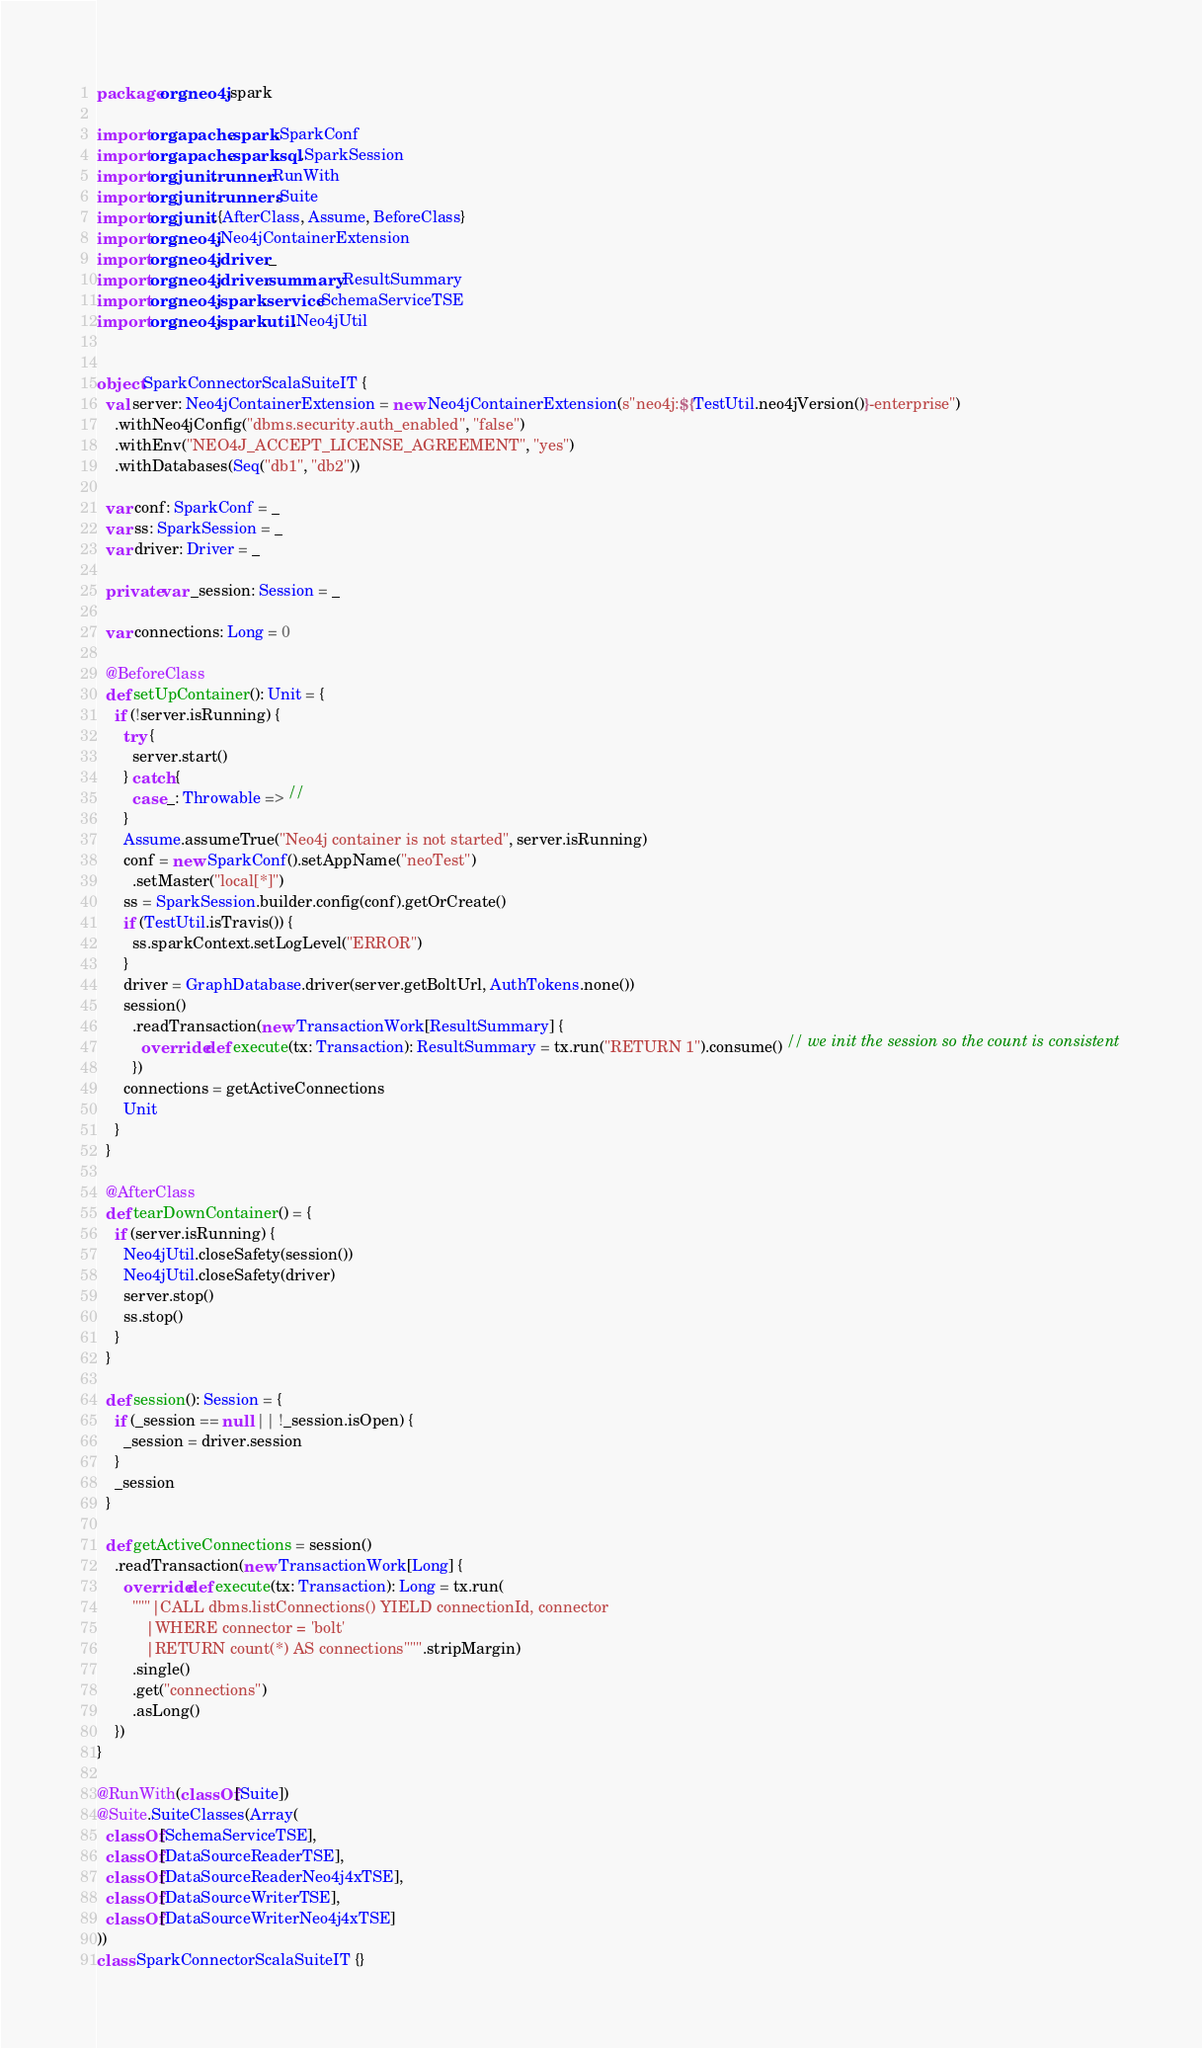Convert code to text. <code><loc_0><loc_0><loc_500><loc_500><_Scala_>package org.neo4j.spark

import org.apache.spark.SparkConf
import org.apache.spark.sql.SparkSession
import org.junit.runner.RunWith
import org.junit.runners.Suite
import org.junit.{AfterClass, Assume, BeforeClass}
import org.neo4j.Neo4jContainerExtension
import org.neo4j.driver._
import org.neo4j.driver.summary.ResultSummary
import org.neo4j.spark.service.SchemaServiceTSE
import org.neo4j.spark.util.Neo4jUtil


object SparkConnectorScalaSuiteIT {
  val server: Neo4jContainerExtension = new Neo4jContainerExtension(s"neo4j:${TestUtil.neo4jVersion()}-enterprise")
    .withNeo4jConfig("dbms.security.auth_enabled", "false")
    .withEnv("NEO4J_ACCEPT_LICENSE_AGREEMENT", "yes")
    .withDatabases(Seq("db1", "db2"))

  var conf: SparkConf = _
  var ss: SparkSession = _
  var driver: Driver = _

  private var _session: Session = _

  var connections: Long = 0

  @BeforeClass
  def setUpContainer(): Unit = {
    if (!server.isRunning) {
      try {
        server.start()
      } catch {
        case _: Throwable => //
      }
      Assume.assumeTrue("Neo4j container is not started", server.isRunning)
      conf = new SparkConf().setAppName("neoTest")
        .setMaster("local[*]")
      ss = SparkSession.builder.config(conf).getOrCreate()
      if (TestUtil.isTravis()) {
        ss.sparkContext.setLogLevel("ERROR")
      }
      driver = GraphDatabase.driver(server.getBoltUrl, AuthTokens.none())
      session()
        .readTransaction(new TransactionWork[ResultSummary] {
          override def execute(tx: Transaction): ResultSummary = tx.run("RETURN 1").consume() // we init the session so the count is consistent
        })
      connections = getActiveConnections
      Unit
    }
  }

  @AfterClass
  def tearDownContainer() = {
    if (server.isRunning) {
      Neo4jUtil.closeSafety(session())
      Neo4jUtil.closeSafety(driver)
      server.stop()
      ss.stop()
    }
  }

  def session(): Session = {
    if (_session == null || !_session.isOpen) {
      _session = driver.session
    }
    _session
  }

  def getActiveConnections = session()
    .readTransaction(new TransactionWork[Long] {
      override def execute(tx: Transaction): Long = tx.run(
        """|CALL dbms.listConnections() YIELD connectionId, connector
           |WHERE connector = 'bolt'
           |RETURN count(*) AS connections""".stripMargin)
        .single()
        .get("connections")
        .asLong()
    })
}

@RunWith(classOf[Suite])
@Suite.SuiteClasses(Array(
  classOf[SchemaServiceTSE],
  classOf[DataSourceReaderTSE],
  classOf[DataSourceReaderNeo4j4xTSE],
  classOf[DataSourceWriterTSE],
  classOf[DataSourceWriterNeo4j4xTSE]
))
class SparkConnectorScalaSuiteIT {}
</code> 